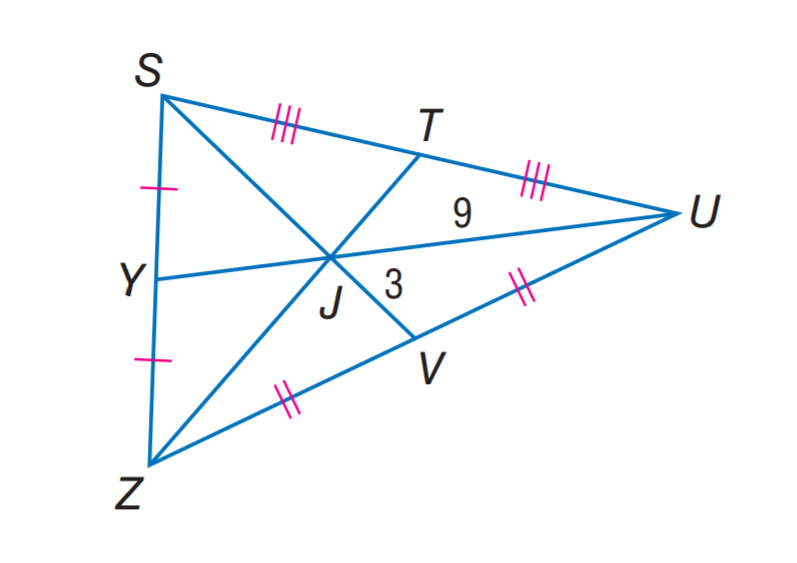Answer the mathemtical geometry problem and directly provide the correct option letter.
Question: U J = 9, V J = 3, and Z T = 18. Find J T.
Choices: A: 3 B: 6 C: 9 D: 12 B 